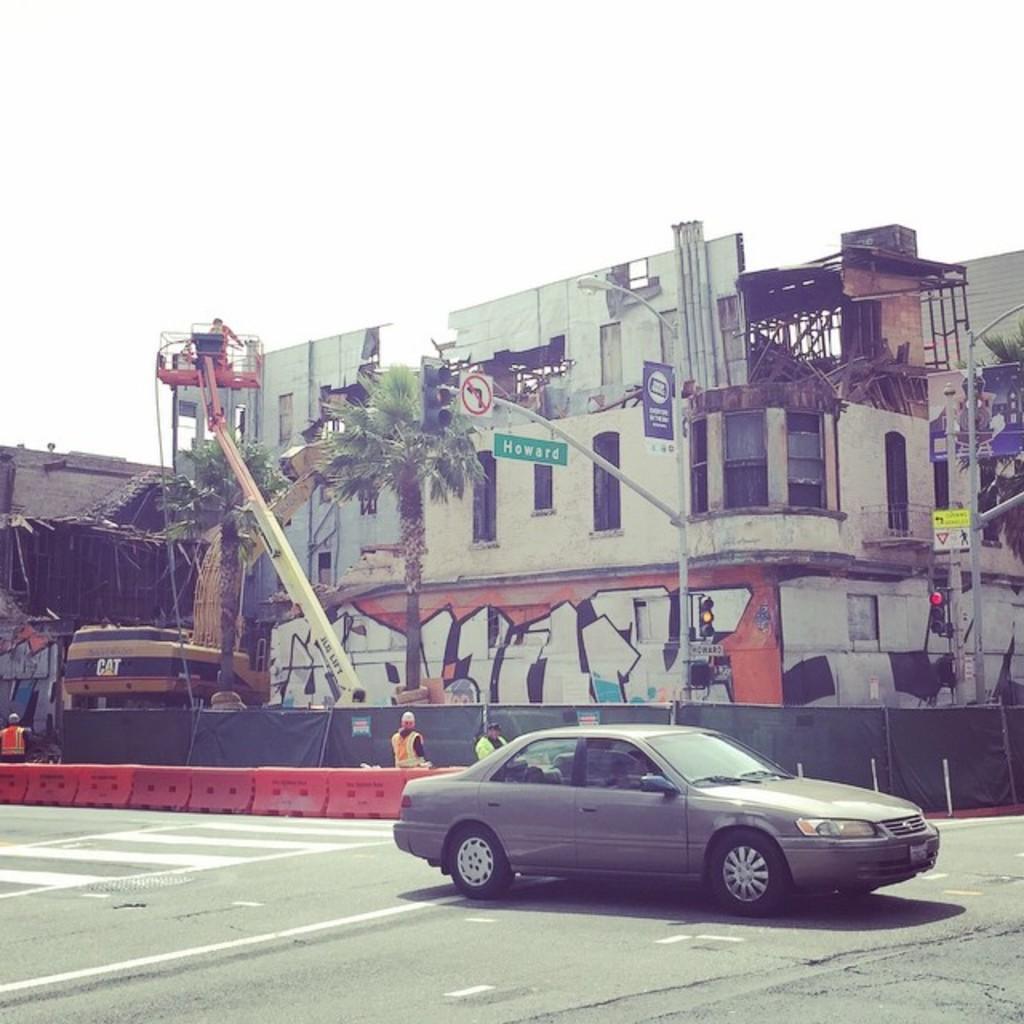In one or two sentences, can you explain what this image depicts? In this image we can see the buildings. In front of the buildings we can see the cranes, trees, poles, traffic lights and boards with text. On the crane we can see a person. In the foreground we can see barriers, car and persons. At the top we can see the sky. 